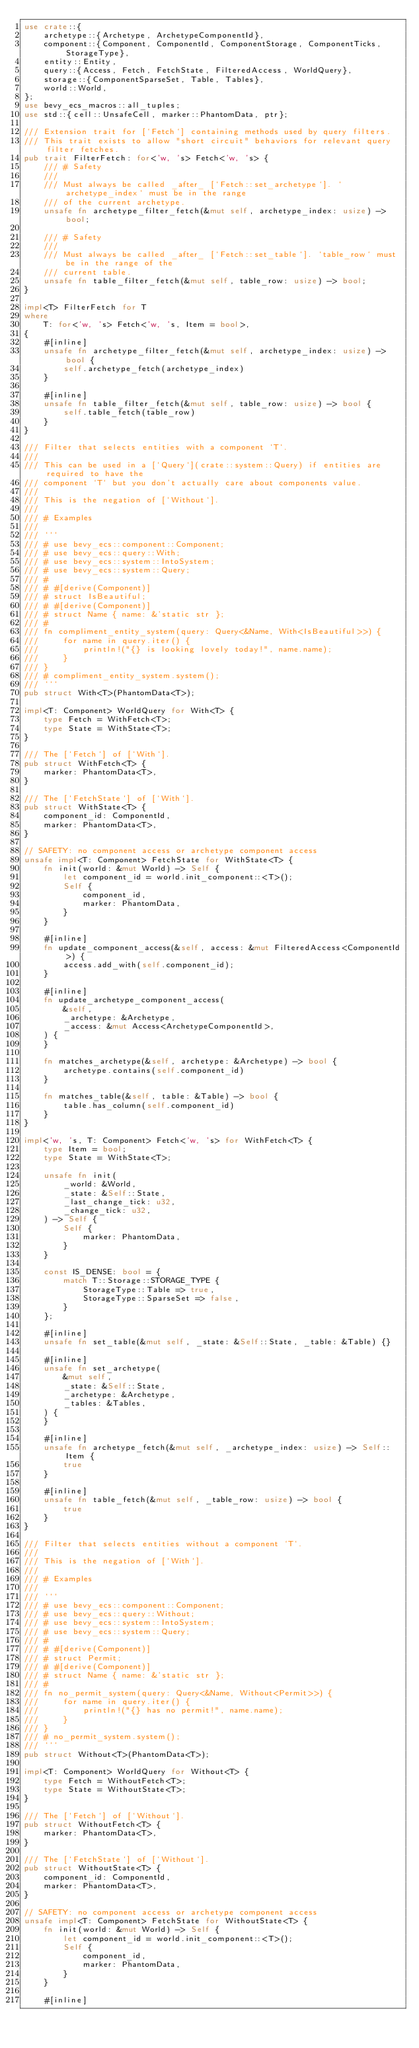Convert code to text. <code><loc_0><loc_0><loc_500><loc_500><_Rust_>use crate::{
    archetype::{Archetype, ArchetypeComponentId},
    component::{Component, ComponentId, ComponentStorage, ComponentTicks, StorageType},
    entity::Entity,
    query::{Access, Fetch, FetchState, FilteredAccess, WorldQuery},
    storage::{ComponentSparseSet, Table, Tables},
    world::World,
};
use bevy_ecs_macros::all_tuples;
use std::{cell::UnsafeCell, marker::PhantomData, ptr};

/// Extension trait for [`Fetch`] containing methods used by query filters.
/// This trait exists to allow "short circuit" behaviors for relevant query filter fetches.
pub trait FilterFetch: for<'w, 's> Fetch<'w, 's> {
    /// # Safety
    ///
    /// Must always be called _after_ [`Fetch::set_archetype`]. `archetype_index` must be in the range
    /// of the current archetype.
    unsafe fn archetype_filter_fetch(&mut self, archetype_index: usize) -> bool;

    /// # Safety
    ///
    /// Must always be called _after_ [`Fetch::set_table`]. `table_row` must be in the range of the
    /// current table.
    unsafe fn table_filter_fetch(&mut self, table_row: usize) -> bool;
}

impl<T> FilterFetch for T
where
    T: for<'w, 's> Fetch<'w, 's, Item = bool>,
{
    #[inline]
    unsafe fn archetype_filter_fetch(&mut self, archetype_index: usize) -> bool {
        self.archetype_fetch(archetype_index)
    }

    #[inline]
    unsafe fn table_filter_fetch(&mut self, table_row: usize) -> bool {
        self.table_fetch(table_row)
    }
}

/// Filter that selects entities with a component `T`.
///
/// This can be used in a [`Query`](crate::system::Query) if entities are required to have the
/// component `T` but you don't actually care about components value.
///
/// This is the negation of [`Without`].
///
/// # Examples
///
/// ```
/// # use bevy_ecs::component::Component;
/// # use bevy_ecs::query::With;
/// # use bevy_ecs::system::IntoSystem;
/// # use bevy_ecs::system::Query;
/// #
/// # #[derive(Component)]
/// # struct IsBeautiful;
/// # #[derive(Component)]
/// # struct Name { name: &'static str };
/// #
/// fn compliment_entity_system(query: Query<&Name, With<IsBeautiful>>) {
///     for name in query.iter() {
///         println!("{} is looking lovely today!", name.name);
///     }
/// }
/// # compliment_entity_system.system();
/// ```
pub struct With<T>(PhantomData<T>);

impl<T: Component> WorldQuery for With<T> {
    type Fetch = WithFetch<T>;
    type State = WithState<T>;
}

/// The [`Fetch`] of [`With`].
pub struct WithFetch<T> {
    marker: PhantomData<T>,
}

/// The [`FetchState`] of [`With`].
pub struct WithState<T> {
    component_id: ComponentId,
    marker: PhantomData<T>,
}

// SAFETY: no component access or archetype component access
unsafe impl<T: Component> FetchState for WithState<T> {
    fn init(world: &mut World) -> Self {
        let component_id = world.init_component::<T>();
        Self {
            component_id,
            marker: PhantomData,
        }
    }

    #[inline]
    fn update_component_access(&self, access: &mut FilteredAccess<ComponentId>) {
        access.add_with(self.component_id);
    }

    #[inline]
    fn update_archetype_component_access(
        &self,
        _archetype: &Archetype,
        _access: &mut Access<ArchetypeComponentId>,
    ) {
    }

    fn matches_archetype(&self, archetype: &Archetype) -> bool {
        archetype.contains(self.component_id)
    }

    fn matches_table(&self, table: &Table) -> bool {
        table.has_column(self.component_id)
    }
}

impl<'w, 's, T: Component> Fetch<'w, 's> for WithFetch<T> {
    type Item = bool;
    type State = WithState<T>;

    unsafe fn init(
        _world: &World,
        _state: &Self::State,
        _last_change_tick: u32,
        _change_tick: u32,
    ) -> Self {
        Self {
            marker: PhantomData,
        }
    }

    const IS_DENSE: bool = {
        match T::Storage::STORAGE_TYPE {
            StorageType::Table => true,
            StorageType::SparseSet => false,
        }
    };

    #[inline]
    unsafe fn set_table(&mut self, _state: &Self::State, _table: &Table) {}

    #[inline]
    unsafe fn set_archetype(
        &mut self,
        _state: &Self::State,
        _archetype: &Archetype,
        _tables: &Tables,
    ) {
    }

    #[inline]
    unsafe fn archetype_fetch(&mut self, _archetype_index: usize) -> Self::Item {
        true
    }

    #[inline]
    unsafe fn table_fetch(&mut self, _table_row: usize) -> bool {
        true
    }
}

/// Filter that selects entities without a component `T`.
///
/// This is the negation of [`With`].
///
/// # Examples
///
/// ```
/// # use bevy_ecs::component::Component;
/// # use bevy_ecs::query::Without;
/// # use bevy_ecs::system::IntoSystem;
/// # use bevy_ecs::system::Query;
/// #
/// # #[derive(Component)]
/// # struct Permit;
/// # #[derive(Component)]
/// # struct Name { name: &'static str };
/// #
/// fn no_permit_system(query: Query<&Name, Without<Permit>>) {
///     for name in query.iter() {
///         println!("{} has no permit!", name.name);
///     }
/// }
/// # no_permit_system.system();
/// ```
pub struct Without<T>(PhantomData<T>);

impl<T: Component> WorldQuery for Without<T> {
    type Fetch = WithoutFetch<T>;
    type State = WithoutState<T>;
}

/// The [`Fetch`] of [`Without`].
pub struct WithoutFetch<T> {
    marker: PhantomData<T>,
}

/// The [`FetchState`] of [`Without`].
pub struct WithoutState<T> {
    component_id: ComponentId,
    marker: PhantomData<T>,
}

// SAFETY: no component access or archetype component access
unsafe impl<T: Component> FetchState for WithoutState<T> {
    fn init(world: &mut World) -> Self {
        let component_id = world.init_component::<T>();
        Self {
            component_id,
            marker: PhantomData,
        }
    }

    #[inline]</code> 